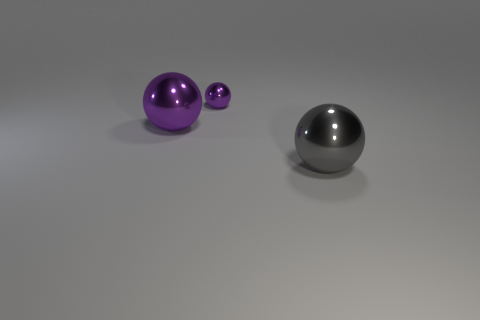Subtract all green balls. Subtract all brown cylinders. How many balls are left? 3 Add 1 tiny shiny things. How many objects exist? 4 Add 2 metallic objects. How many metallic objects exist? 5 Subtract 0 green blocks. How many objects are left? 3 Subtract all gray shiny balls. Subtract all tiny metal things. How many objects are left? 1 Add 3 big balls. How many big balls are left? 5 